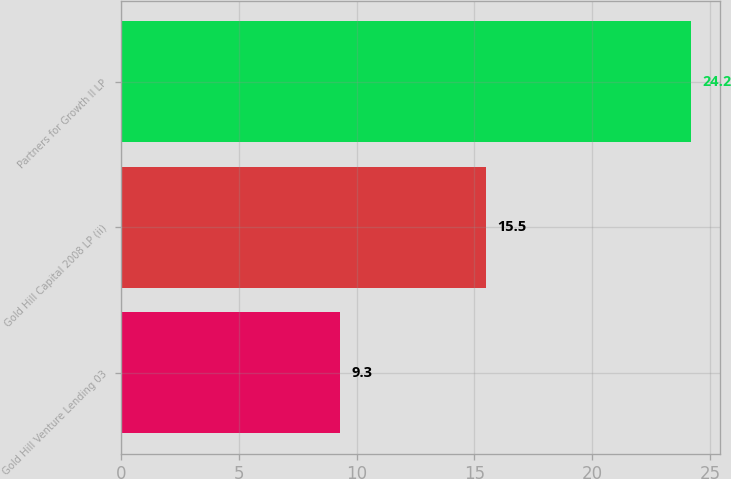<chart> <loc_0><loc_0><loc_500><loc_500><bar_chart><fcel>Gold Hill Venture Lending 03<fcel>Gold Hill Capital 2008 LP (ii)<fcel>Partners for Growth II LP<nl><fcel>9.3<fcel>15.5<fcel>24.2<nl></chart> 